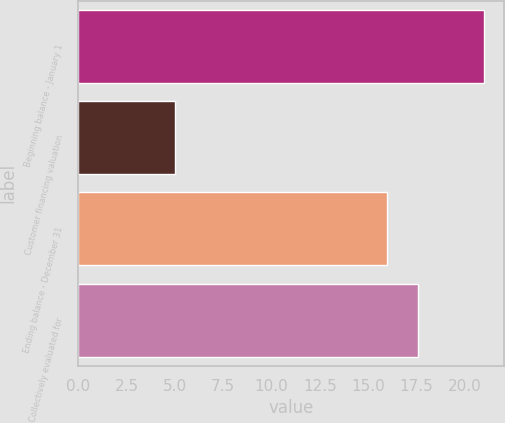Convert chart. <chart><loc_0><loc_0><loc_500><loc_500><bar_chart><fcel>Beginning balance - January 1<fcel>Customer financing valuation<fcel>Ending balance - December 31<fcel>Collectively evaluated for<nl><fcel>21<fcel>5<fcel>16<fcel>17.6<nl></chart> 